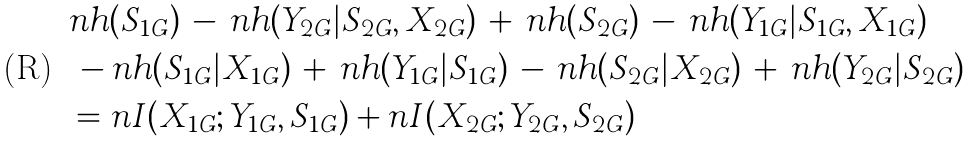Convert formula to latex. <formula><loc_0><loc_0><loc_500><loc_500>& n h ( S _ { 1 G } ) \, - \, n h ( Y _ { 2 G } | S _ { 2 G } , X _ { 2 G } ) \, + \, n h ( S _ { 2 G } ) \, - \, n h ( Y _ { 1 G } | S _ { 1 G } , X _ { 1 G } ) \\ & \, - n h ( S _ { 1 G } | X _ { 1 G } ) \, + \, n h ( Y _ { 1 G } | S _ { 1 G } ) \, - \, n h ( S _ { 2 G } | X _ { 2 G } ) \, + \, n h ( Y _ { 2 G } | S _ { 2 G } ) \\ & = n I ( X _ { 1 G } ; Y _ { 1 G } , S _ { 1 G } ) + n I ( X _ { 2 G } ; Y _ { 2 G } , S _ { 2 G } )</formula> 